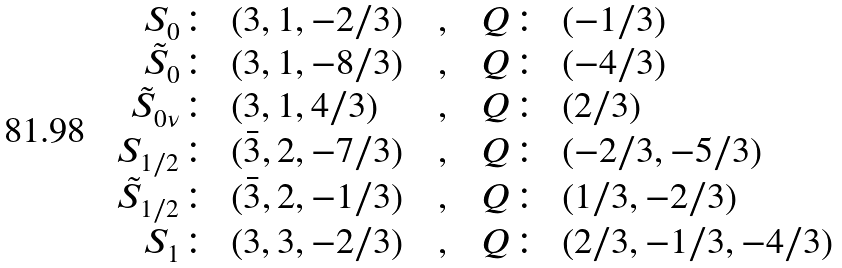<formula> <loc_0><loc_0><loc_500><loc_500>\begin{array} { r l c r l } S _ { 0 } \colon & ( 3 , 1 , - 2 / 3 ) \ \ & , & \ \ Q \colon & ( - 1 / 3 ) \\ \tilde { S } _ { 0 } \colon & ( 3 , 1 , - 8 / 3 ) \ \ & , & \ \ Q \colon & ( - 4 / 3 ) \\ \tilde { S } _ { 0 \nu } \colon & ( 3 , 1 , 4 / 3 ) \ \ & , & \ \ Q \colon & ( 2 / 3 ) \\ S _ { 1 / 2 } \colon & ( \bar { 3 } , 2 , - 7 / 3 ) \ \ & , & \ \ Q \colon & ( - 2 / 3 , - 5 / 3 ) \\ \tilde { S } _ { 1 / 2 } \colon & ( \bar { 3 } , 2 , - 1 / 3 ) \ \ & , & \ \ Q \colon & ( 1 / 3 , - 2 / 3 ) \\ S _ { 1 } \colon & ( 3 , 3 , - 2 / 3 ) \ \ & , & \ \ Q \colon & ( 2 / 3 , - 1 / 3 , - 4 / 3 ) \end{array}</formula> 